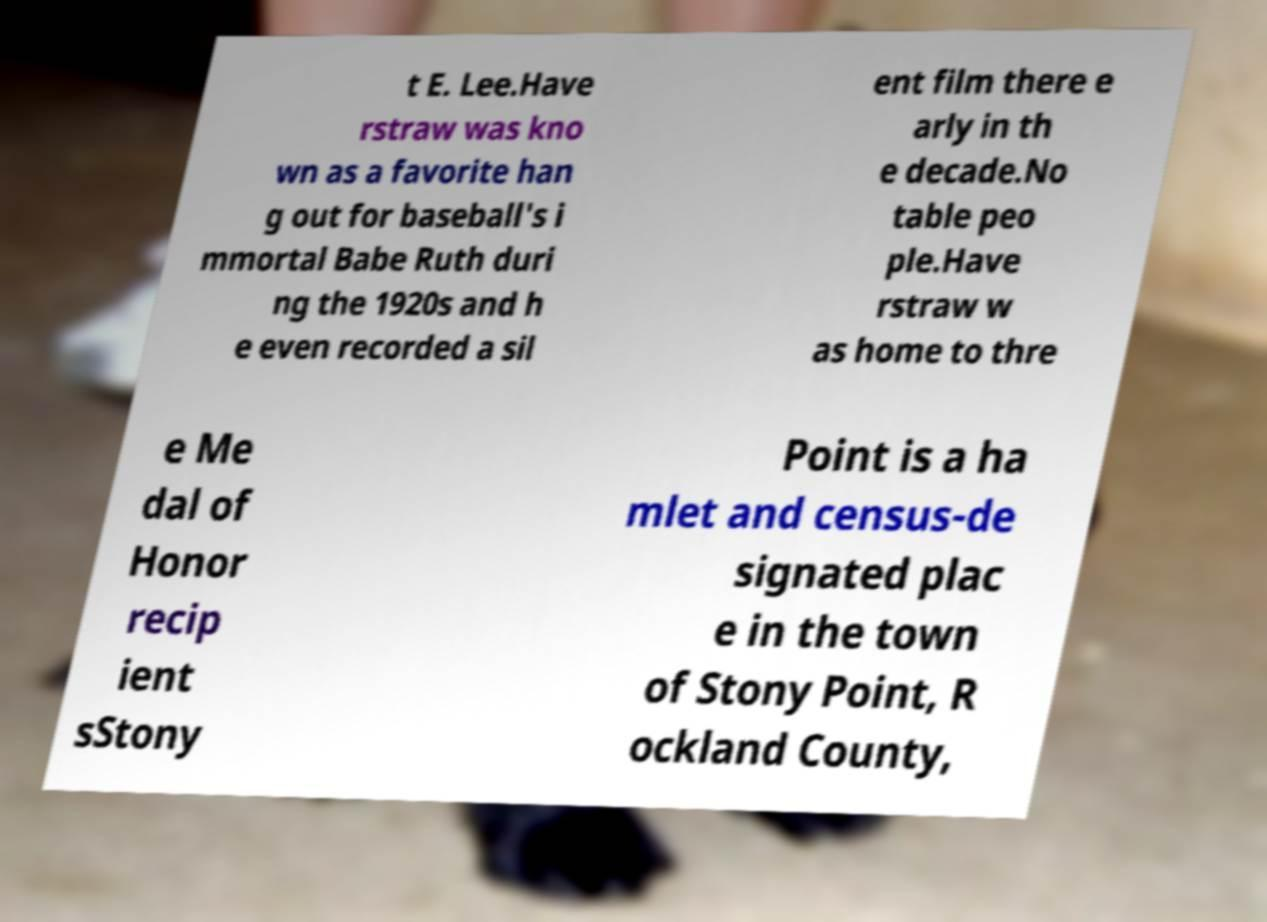For documentation purposes, I need the text within this image transcribed. Could you provide that? t E. Lee.Have rstraw was kno wn as a favorite han g out for baseball's i mmortal Babe Ruth duri ng the 1920s and h e even recorded a sil ent film there e arly in th e decade.No table peo ple.Have rstraw w as home to thre e Me dal of Honor recip ient sStony Point is a ha mlet and census-de signated plac e in the town of Stony Point, R ockland County, 